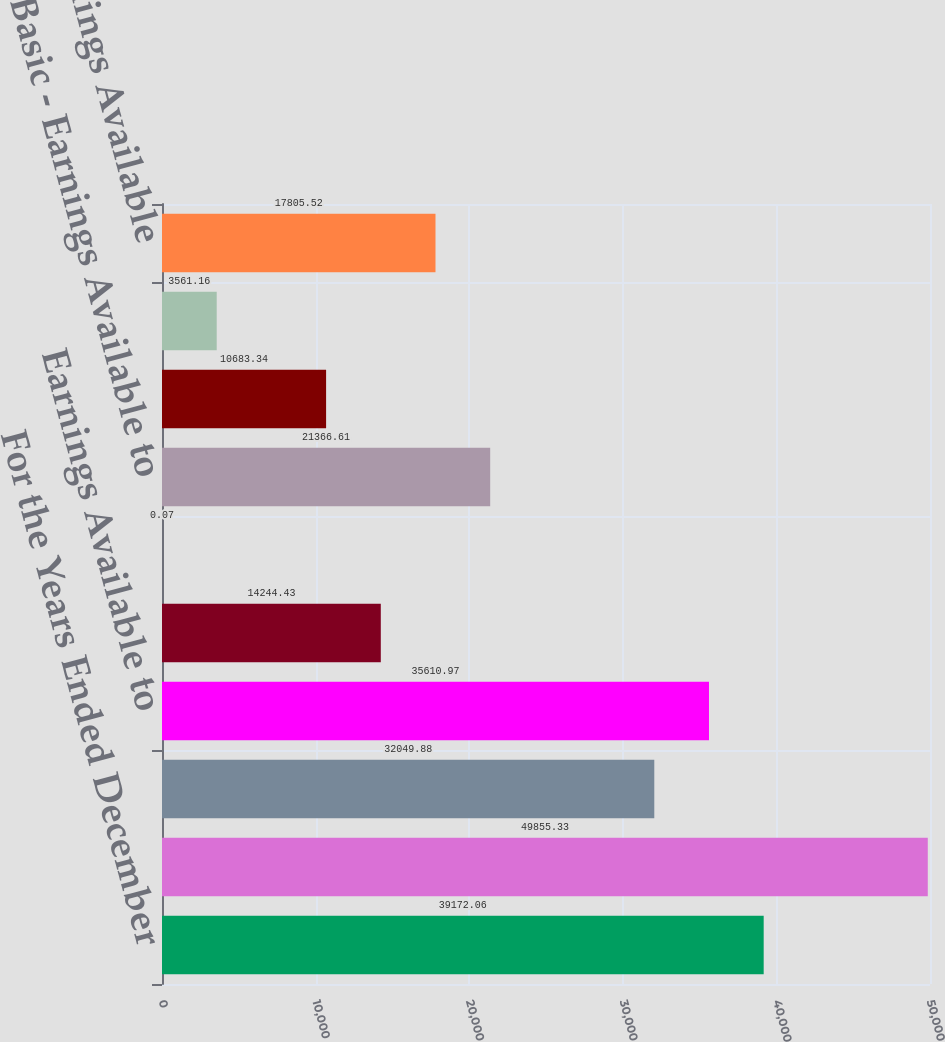Convert chart. <chart><loc_0><loc_0><loc_500><loc_500><bar_chart><fcel>For the Years Ended December<fcel>Revenues<fcel>Income From Continuing<fcel>Earnings Available to<fcel>Basic - Continuing Operations<fcel>Basic - Discontinued<fcel>Basic - Earnings Available to<fcel>Diluted - Continuing<fcel>Diluted - Discontinued<fcel>Diluted - Earnings Available<nl><fcel>39172.1<fcel>49855.3<fcel>32049.9<fcel>35611<fcel>14244.4<fcel>0.07<fcel>21366.6<fcel>10683.3<fcel>3561.16<fcel>17805.5<nl></chart> 